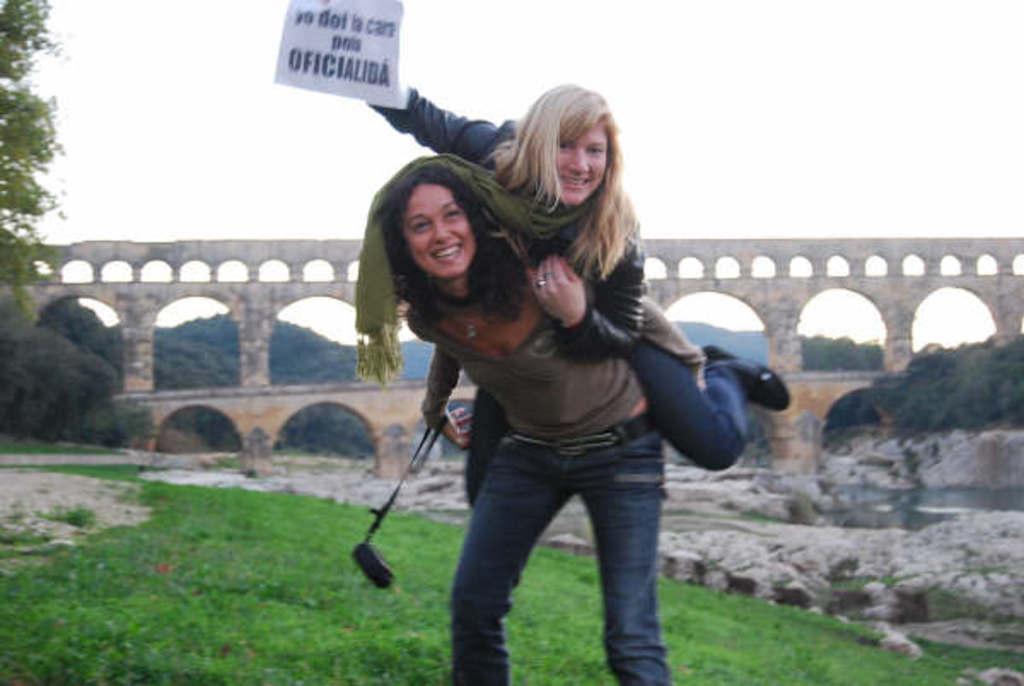Can you describe this image briefly? In this image we can see a woman standing on the ground holding a device and carrying a woman who is holding a paper containing some text on it. We can also see some grass, stones, water, a group of trees, a bridge with stone pillars and the sky. 